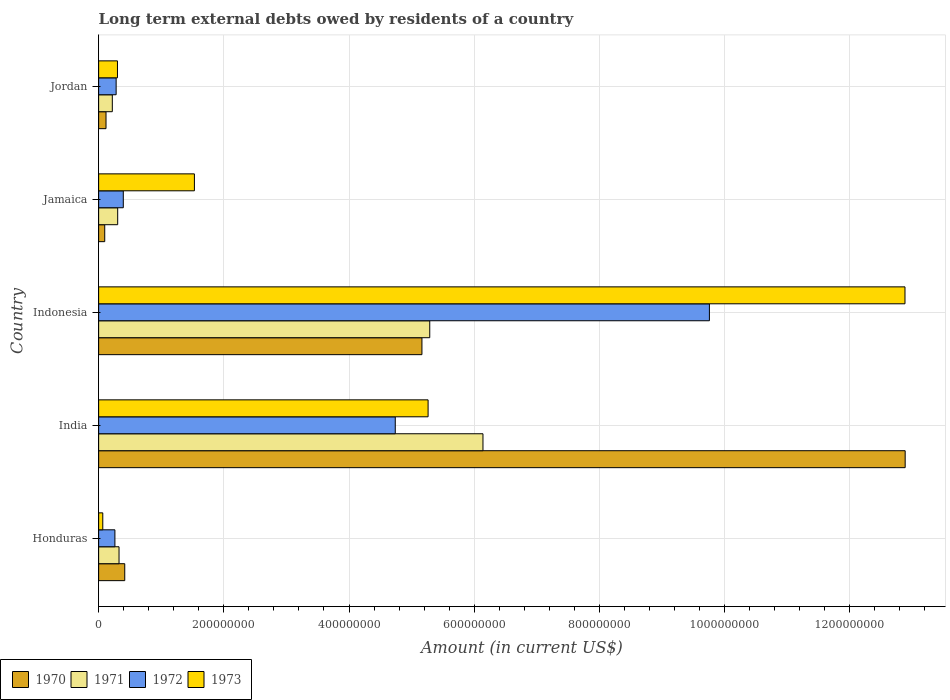How many groups of bars are there?
Ensure brevity in your answer.  5. Are the number of bars on each tick of the Y-axis equal?
Your response must be concise. Yes. How many bars are there on the 3rd tick from the top?
Provide a succinct answer. 4. What is the label of the 2nd group of bars from the top?
Provide a succinct answer. Jamaica. What is the amount of long-term external debts owed by residents in 1973 in Jamaica?
Offer a terse response. 1.53e+08. Across all countries, what is the maximum amount of long-term external debts owed by residents in 1973?
Make the answer very short. 1.29e+09. Across all countries, what is the minimum amount of long-term external debts owed by residents in 1972?
Your answer should be compact. 2.60e+07. In which country was the amount of long-term external debts owed by residents in 1970 maximum?
Ensure brevity in your answer.  India. In which country was the amount of long-term external debts owed by residents in 1973 minimum?
Your answer should be very brief. Honduras. What is the total amount of long-term external debts owed by residents in 1970 in the graph?
Provide a short and direct response. 1.87e+09. What is the difference between the amount of long-term external debts owed by residents in 1973 in India and that in Indonesia?
Provide a succinct answer. -7.62e+08. What is the difference between the amount of long-term external debts owed by residents in 1971 in Honduras and the amount of long-term external debts owed by residents in 1972 in Indonesia?
Your response must be concise. -9.43e+08. What is the average amount of long-term external debts owed by residents in 1971 per country?
Offer a terse response. 2.46e+08. What is the difference between the amount of long-term external debts owed by residents in 1971 and amount of long-term external debts owed by residents in 1973 in India?
Your response must be concise. 8.77e+07. In how many countries, is the amount of long-term external debts owed by residents in 1973 greater than 280000000 US$?
Provide a succinct answer. 2. What is the ratio of the amount of long-term external debts owed by residents in 1973 in Indonesia to that in Jamaica?
Ensure brevity in your answer.  8.42. Is the amount of long-term external debts owed by residents in 1970 in Honduras less than that in Jamaica?
Your answer should be very brief. No. What is the difference between the highest and the second highest amount of long-term external debts owed by residents in 1971?
Keep it short and to the point. 8.50e+07. What is the difference between the highest and the lowest amount of long-term external debts owed by residents in 1970?
Give a very brief answer. 1.28e+09. In how many countries, is the amount of long-term external debts owed by residents in 1972 greater than the average amount of long-term external debts owed by residents in 1972 taken over all countries?
Offer a very short reply. 2. Is it the case that in every country, the sum of the amount of long-term external debts owed by residents in 1972 and amount of long-term external debts owed by residents in 1973 is greater than the amount of long-term external debts owed by residents in 1970?
Ensure brevity in your answer.  No. Are all the bars in the graph horizontal?
Ensure brevity in your answer.  Yes. What is the difference between two consecutive major ticks on the X-axis?
Your answer should be very brief. 2.00e+08. Does the graph contain grids?
Offer a very short reply. Yes. Where does the legend appear in the graph?
Your response must be concise. Bottom left. How are the legend labels stacked?
Provide a short and direct response. Horizontal. What is the title of the graph?
Your answer should be compact. Long term external debts owed by residents of a country. Does "1994" appear as one of the legend labels in the graph?
Your answer should be compact. No. What is the label or title of the X-axis?
Offer a terse response. Amount (in current US$). What is the Amount (in current US$) in 1970 in Honduras?
Keep it short and to the point. 4.17e+07. What is the Amount (in current US$) of 1971 in Honduras?
Offer a terse response. 3.26e+07. What is the Amount (in current US$) in 1972 in Honduras?
Your answer should be very brief. 2.60e+07. What is the Amount (in current US$) of 1973 in Honduras?
Keep it short and to the point. 6.62e+06. What is the Amount (in current US$) in 1970 in India?
Offer a terse response. 1.29e+09. What is the Amount (in current US$) of 1971 in India?
Your answer should be very brief. 6.14e+08. What is the Amount (in current US$) in 1972 in India?
Keep it short and to the point. 4.74e+08. What is the Amount (in current US$) in 1973 in India?
Keep it short and to the point. 5.26e+08. What is the Amount (in current US$) of 1970 in Indonesia?
Make the answer very short. 5.17e+08. What is the Amount (in current US$) of 1971 in Indonesia?
Your answer should be compact. 5.29e+08. What is the Amount (in current US$) in 1972 in Indonesia?
Give a very brief answer. 9.76e+08. What is the Amount (in current US$) of 1973 in Indonesia?
Provide a succinct answer. 1.29e+09. What is the Amount (in current US$) in 1970 in Jamaica?
Your answer should be very brief. 9.74e+06. What is the Amount (in current US$) in 1971 in Jamaica?
Provide a short and direct response. 3.04e+07. What is the Amount (in current US$) in 1972 in Jamaica?
Offer a very short reply. 3.94e+07. What is the Amount (in current US$) of 1973 in Jamaica?
Your answer should be very brief. 1.53e+08. What is the Amount (in current US$) of 1970 in Jordan?
Make the answer very short. 1.18e+07. What is the Amount (in current US$) of 1971 in Jordan?
Your response must be concise. 2.18e+07. What is the Amount (in current US$) of 1972 in Jordan?
Your answer should be compact. 2.80e+07. What is the Amount (in current US$) of 1973 in Jordan?
Provide a short and direct response. 3.01e+07. Across all countries, what is the maximum Amount (in current US$) in 1970?
Offer a very short reply. 1.29e+09. Across all countries, what is the maximum Amount (in current US$) in 1971?
Ensure brevity in your answer.  6.14e+08. Across all countries, what is the maximum Amount (in current US$) in 1972?
Give a very brief answer. 9.76e+08. Across all countries, what is the maximum Amount (in current US$) in 1973?
Provide a short and direct response. 1.29e+09. Across all countries, what is the minimum Amount (in current US$) in 1970?
Make the answer very short. 9.74e+06. Across all countries, what is the minimum Amount (in current US$) of 1971?
Provide a short and direct response. 2.18e+07. Across all countries, what is the minimum Amount (in current US$) in 1972?
Your answer should be compact. 2.60e+07. Across all countries, what is the minimum Amount (in current US$) of 1973?
Keep it short and to the point. 6.62e+06. What is the total Amount (in current US$) in 1970 in the graph?
Provide a short and direct response. 1.87e+09. What is the total Amount (in current US$) of 1971 in the graph?
Give a very brief answer. 1.23e+09. What is the total Amount (in current US$) in 1972 in the graph?
Your answer should be compact. 1.54e+09. What is the total Amount (in current US$) in 1973 in the graph?
Your response must be concise. 2.00e+09. What is the difference between the Amount (in current US$) in 1970 in Honduras and that in India?
Provide a succinct answer. -1.25e+09. What is the difference between the Amount (in current US$) of 1971 in Honduras and that in India?
Give a very brief answer. -5.81e+08. What is the difference between the Amount (in current US$) of 1972 in Honduras and that in India?
Ensure brevity in your answer.  -4.48e+08. What is the difference between the Amount (in current US$) in 1973 in Honduras and that in India?
Make the answer very short. -5.20e+08. What is the difference between the Amount (in current US$) in 1970 in Honduras and that in Indonesia?
Provide a succinct answer. -4.75e+08. What is the difference between the Amount (in current US$) in 1971 in Honduras and that in Indonesia?
Your response must be concise. -4.96e+08. What is the difference between the Amount (in current US$) in 1972 in Honduras and that in Indonesia?
Your answer should be compact. -9.50e+08. What is the difference between the Amount (in current US$) of 1973 in Honduras and that in Indonesia?
Offer a terse response. -1.28e+09. What is the difference between the Amount (in current US$) of 1970 in Honduras and that in Jamaica?
Offer a very short reply. 3.20e+07. What is the difference between the Amount (in current US$) of 1971 in Honduras and that in Jamaica?
Provide a succinct answer. 2.17e+06. What is the difference between the Amount (in current US$) of 1972 in Honduras and that in Jamaica?
Your response must be concise. -1.34e+07. What is the difference between the Amount (in current US$) in 1973 in Honduras and that in Jamaica?
Your response must be concise. -1.46e+08. What is the difference between the Amount (in current US$) in 1970 in Honduras and that in Jordan?
Give a very brief answer. 2.99e+07. What is the difference between the Amount (in current US$) of 1971 in Honduras and that in Jordan?
Make the answer very short. 1.08e+07. What is the difference between the Amount (in current US$) in 1972 in Honduras and that in Jordan?
Your response must be concise. -1.96e+06. What is the difference between the Amount (in current US$) in 1973 in Honduras and that in Jordan?
Make the answer very short. -2.35e+07. What is the difference between the Amount (in current US$) of 1970 in India and that in Indonesia?
Your response must be concise. 7.72e+08. What is the difference between the Amount (in current US$) of 1971 in India and that in Indonesia?
Make the answer very short. 8.50e+07. What is the difference between the Amount (in current US$) of 1972 in India and that in Indonesia?
Give a very brief answer. -5.02e+08. What is the difference between the Amount (in current US$) of 1973 in India and that in Indonesia?
Your answer should be very brief. -7.62e+08. What is the difference between the Amount (in current US$) in 1970 in India and that in Jamaica?
Give a very brief answer. 1.28e+09. What is the difference between the Amount (in current US$) in 1971 in India and that in Jamaica?
Your response must be concise. 5.84e+08. What is the difference between the Amount (in current US$) in 1972 in India and that in Jamaica?
Your answer should be compact. 4.34e+08. What is the difference between the Amount (in current US$) in 1973 in India and that in Jamaica?
Your answer should be very brief. 3.73e+08. What is the difference between the Amount (in current US$) in 1970 in India and that in Jordan?
Offer a very short reply. 1.28e+09. What is the difference between the Amount (in current US$) in 1971 in India and that in Jordan?
Your response must be concise. 5.92e+08. What is the difference between the Amount (in current US$) in 1972 in India and that in Jordan?
Your answer should be very brief. 4.46e+08. What is the difference between the Amount (in current US$) of 1973 in India and that in Jordan?
Offer a terse response. 4.96e+08. What is the difference between the Amount (in current US$) of 1970 in Indonesia and that in Jamaica?
Offer a terse response. 5.07e+08. What is the difference between the Amount (in current US$) in 1971 in Indonesia and that in Jamaica?
Your answer should be compact. 4.99e+08. What is the difference between the Amount (in current US$) in 1972 in Indonesia and that in Jamaica?
Ensure brevity in your answer.  9.36e+08. What is the difference between the Amount (in current US$) in 1973 in Indonesia and that in Jamaica?
Keep it short and to the point. 1.14e+09. What is the difference between the Amount (in current US$) in 1970 in Indonesia and that in Jordan?
Provide a succinct answer. 5.05e+08. What is the difference between the Amount (in current US$) in 1971 in Indonesia and that in Jordan?
Give a very brief answer. 5.07e+08. What is the difference between the Amount (in current US$) in 1972 in Indonesia and that in Jordan?
Provide a short and direct response. 9.48e+08. What is the difference between the Amount (in current US$) of 1973 in Indonesia and that in Jordan?
Make the answer very short. 1.26e+09. What is the difference between the Amount (in current US$) of 1970 in Jamaica and that in Jordan?
Make the answer very short. -2.06e+06. What is the difference between the Amount (in current US$) in 1971 in Jamaica and that in Jordan?
Your answer should be compact. 8.59e+06. What is the difference between the Amount (in current US$) of 1972 in Jamaica and that in Jordan?
Keep it short and to the point. 1.14e+07. What is the difference between the Amount (in current US$) of 1973 in Jamaica and that in Jordan?
Your answer should be very brief. 1.23e+08. What is the difference between the Amount (in current US$) of 1970 in Honduras and the Amount (in current US$) of 1971 in India?
Give a very brief answer. -5.72e+08. What is the difference between the Amount (in current US$) in 1970 in Honduras and the Amount (in current US$) in 1972 in India?
Provide a short and direct response. -4.32e+08. What is the difference between the Amount (in current US$) of 1970 in Honduras and the Amount (in current US$) of 1973 in India?
Your response must be concise. -4.85e+08. What is the difference between the Amount (in current US$) of 1971 in Honduras and the Amount (in current US$) of 1972 in India?
Give a very brief answer. -4.41e+08. What is the difference between the Amount (in current US$) in 1971 in Honduras and the Amount (in current US$) in 1973 in India?
Give a very brief answer. -4.94e+08. What is the difference between the Amount (in current US$) in 1972 in Honduras and the Amount (in current US$) in 1973 in India?
Your response must be concise. -5.00e+08. What is the difference between the Amount (in current US$) in 1970 in Honduras and the Amount (in current US$) in 1971 in Indonesia?
Ensure brevity in your answer.  -4.87e+08. What is the difference between the Amount (in current US$) in 1970 in Honduras and the Amount (in current US$) in 1972 in Indonesia?
Provide a succinct answer. -9.34e+08. What is the difference between the Amount (in current US$) of 1970 in Honduras and the Amount (in current US$) of 1973 in Indonesia?
Offer a very short reply. -1.25e+09. What is the difference between the Amount (in current US$) of 1971 in Honduras and the Amount (in current US$) of 1972 in Indonesia?
Your response must be concise. -9.43e+08. What is the difference between the Amount (in current US$) in 1971 in Honduras and the Amount (in current US$) in 1973 in Indonesia?
Make the answer very short. -1.26e+09. What is the difference between the Amount (in current US$) in 1972 in Honduras and the Amount (in current US$) in 1973 in Indonesia?
Ensure brevity in your answer.  -1.26e+09. What is the difference between the Amount (in current US$) of 1970 in Honduras and the Amount (in current US$) of 1971 in Jamaica?
Offer a terse response. 1.13e+07. What is the difference between the Amount (in current US$) of 1970 in Honduras and the Amount (in current US$) of 1972 in Jamaica?
Provide a succinct answer. 2.33e+06. What is the difference between the Amount (in current US$) of 1970 in Honduras and the Amount (in current US$) of 1973 in Jamaica?
Your answer should be very brief. -1.11e+08. What is the difference between the Amount (in current US$) in 1971 in Honduras and the Amount (in current US$) in 1972 in Jamaica?
Provide a succinct answer. -6.81e+06. What is the difference between the Amount (in current US$) in 1971 in Honduras and the Amount (in current US$) in 1973 in Jamaica?
Your answer should be compact. -1.20e+08. What is the difference between the Amount (in current US$) of 1972 in Honduras and the Amount (in current US$) of 1973 in Jamaica?
Your answer should be very brief. -1.27e+08. What is the difference between the Amount (in current US$) of 1970 in Honduras and the Amount (in current US$) of 1971 in Jordan?
Your answer should be compact. 1.99e+07. What is the difference between the Amount (in current US$) in 1970 in Honduras and the Amount (in current US$) in 1972 in Jordan?
Offer a very short reply. 1.38e+07. What is the difference between the Amount (in current US$) in 1970 in Honduras and the Amount (in current US$) in 1973 in Jordan?
Your answer should be very brief. 1.16e+07. What is the difference between the Amount (in current US$) of 1971 in Honduras and the Amount (in current US$) of 1972 in Jordan?
Offer a terse response. 4.63e+06. What is the difference between the Amount (in current US$) of 1971 in Honduras and the Amount (in current US$) of 1973 in Jordan?
Your answer should be very brief. 2.51e+06. What is the difference between the Amount (in current US$) of 1972 in Honduras and the Amount (in current US$) of 1973 in Jordan?
Your answer should be very brief. -4.08e+06. What is the difference between the Amount (in current US$) of 1970 in India and the Amount (in current US$) of 1971 in Indonesia?
Offer a terse response. 7.60e+08. What is the difference between the Amount (in current US$) in 1970 in India and the Amount (in current US$) in 1972 in Indonesia?
Make the answer very short. 3.13e+08. What is the difference between the Amount (in current US$) in 1970 in India and the Amount (in current US$) in 1973 in Indonesia?
Your answer should be very brief. 3.01e+05. What is the difference between the Amount (in current US$) of 1971 in India and the Amount (in current US$) of 1972 in Indonesia?
Provide a succinct answer. -3.62e+08. What is the difference between the Amount (in current US$) in 1971 in India and the Amount (in current US$) in 1973 in Indonesia?
Make the answer very short. -6.74e+08. What is the difference between the Amount (in current US$) in 1972 in India and the Amount (in current US$) in 1973 in Indonesia?
Ensure brevity in your answer.  -8.14e+08. What is the difference between the Amount (in current US$) in 1970 in India and the Amount (in current US$) in 1971 in Jamaica?
Provide a short and direct response. 1.26e+09. What is the difference between the Amount (in current US$) of 1970 in India and the Amount (in current US$) of 1972 in Jamaica?
Offer a terse response. 1.25e+09. What is the difference between the Amount (in current US$) in 1970 in India and the Amount (in current US$) in 1973 in Jamaica?
Your answer should be compact. 1.14e+09. What is the difference between the Amount (in current US$) in 1971 in India and the Amount (in current US$) in 1972 in Jamaica?
Make the answer very short. 5.75e+08. What is the difference between the Amount (in current US$) in 1971 in India and the Amount (in current US$) in 1973 in Jamaica?
Keep it short and to the point. 4.61e+08. What is the difference between the Amount (in current US$) in 1972 in India and the Amount (in current US$) in 1973 in Jamaica?
Provide a short and direct response. 3.21e+08. What is the difference between the Amount (in current US$) in 1970 in India and the Amount (in current US$) in 1971 in Jordan?
Your answer should be very brief. 1.27e+09. What is the difference between the Amount (in current US$) in 1970 in India and the Amount (in current US$) in 1972 in Jordan?
Make the answer very short. 1.26e+09. What is the difference between the Amount (in current US$) in 1970 in India and the Amount (in current US$) in 1973 in Jordan?
Your answer should be very brief. 1.26e+09. What is the difference between the Amount (in current US$) of 1971 in India and the Amount (in current US$) of 1972 in Jordan?
Offer a terse response. 5.86e+08. What is the difference between the Amount (in current US$) in 1971 in India and the Amount (in current US$) in 1973 in Jordan?
Keep it short and to the point. 5.84e+08. What is the difference between the Amount (in current US$) in 1972 in India and the Amount (in current US$) in 1973 in Jordan?
Your response must be concise. 4.44e+08. What is the difference between the Amount (in current US$) in 1970 in Indonesia and the Amount (in current US$) in 1971 in Jamaica?
Your answer should be compact. 4.86e+08. What is the difference between the Amount (in current US$) in 1970 in Indonesia and the Amount (in current US$) in 1972 in Jamaica?
Your response must be concise. 4.77e+08. What is the difference between the Amount (in current US$) in 1970 in Indonesia and the Amount (in current US$) in 1973 in Jamaica?
Provide a succinct answer. 3.64e+08. What is the difference between the Amount (in current US$) of 1971 in Indonesia and the Amount (in current US$) of 1972 in Jamaica?
Your answer should be very brief. 4.90e+08. What is the difference between the Amount (in current US$) in 1971 in Indonesia and the Amount (in current US$) in 1973 in Jamaica?
Your answer should be compact. 3.76e+08. What is the difference between the Amount (in current US$) of 1972 in Indonesia and the Amount (in current US$) of 1973 in Jamaica?
Make the answer very short. 8.23e+08. What is the difference between the Amount (in current US$) of 1970 in Indonesia and the Amount (in current US$) of 1971 in Jordan?
Your answer should be compact. 4.95e+08. What is the difference between the Amount (in current US$) of 1970 in Indonesia and the Amount (in current US$) of 1972 in Jordan?
Provide a short and direct response. 4.89e+08. What is the difference between the Amount (in current US$) in 1970 in Indonesia and the Amount (in current US$) in 1973 in Jordan?
Give a very brief answer. 4.86e+08. What is the difference between the Amount (in current US$) in 1971 in Indonesia and the Amount (in current US$) in 1972 in Jordan?
Offer a very short reply. 5.01e+08. What is the difference between the Amount (in current US$) of 1971 in Indonesia and the Amount (in current US$) of 1973 in Jordan?
Give a very brief answer. 4.99e+08. What is the difference between the Amount (in current US$) of 1972 in Indonesia and the Amount (in current US$) of 1973 in Jordan?
Provide a succinct answer. 9.46e+08. What is the difference between the Amount (in current US$) of 1970 in Jamaica and the Amount (in current US$) of 1971 in Jordan?
Make the answer very short. -1.21e+07. What is the difference between the Amount (in current US$) of 1970 in Jamaica and the Amount (in current US$) of 1972 in Jordan?
Offer a terse response. -1.82e+07. What is the difference between the Amount (in current US$) of 1970 in Jamaica and the Amount (in current US$) of 1973 in Jordan?
Provide a succinct answer. -2.04e+07. What is the difference between the Amount (in current US$) of 1971 in Jamaica and the Amount (in current US$) of 1972 in Jordan?
Provide a short and direct response. 2.46e+06. What is the difference between the Amount (in current US$) of 1971 in Jamaica and the Amount (in current US$) of 1973 in Jordan?
Provide a short and direct response. 3.43e+05. What is the difference between the Amount (in current US$) of 1972 in Jamaica and the Amount (in current US$) of 1973 in Jordan?
Keep it short and to the point. 9.32e+06. What is the average Amount (in current US$) in 1970 per country?
Your answer should be very brief. 3.74e+08. What is the average Amount (in current US$) in 1971 per country?
Offer a very short reply. 2.46e+08. What is the average Amount (in current US$) of 1972 per country?
Give a very brief answer. 3.09e+08. What is the average Amount (in current US$) of 1973 per country?
Your answer should be very brief. 4.01e+08. What is the difference between the Amount (in current US$) in 1970 and Amount (in current US$) in 1971 in Honduras?
Provide a short and direct response. 9.13e+06. What is the difference between the Amount (in current US$) in 1970 and Amount (in current US$) in 1972 in Honduras?
Offer a terse response. 1.57e+07. What is the difference between the Amount (in current US$) of 1970 and Amount (in current US$) of 1973 in Honduras?
Provide a short and direct response. 3.51e+07. What is the difference between the Amount (in current US$) of 1971 and Amount (in current US$) of 1972 in Honduras?
Provide a short and direct response. 6.59e+06. What is the difference between the Amount (in current US$) of 1971 and Amount (in current US$) of 1973 in Honduras?
Your answer should be very brief. 2.60e+07. What is the difference between the Amount (in current US$) in 1972 and Amount (in current US$) in 1973 in Honduras?
Keep it short and to the point. 1.94e+07. What is the difference between the Amount (in current US$) in 1970 and Amount (in current US$) in 1971 in India?
Provide a succinct answer. 6.74e+08. What is the difference between the Amount (in current US$) of 1970 and Amount (in current US$) of 1972 in India?
Provide a short and direct response. 8.15e+08. What is the difference between the Amount (in current US$) of 1970 and Amount (in current US$) of 1973 in India?
Your response must be concise. 7.62e+08. What is the difference between the Amount (in current US$) of 1971 and Amount (in current US$) of 1972 in India?
Your response must be concise. 1.40e+08. What is the difference between the Amount (in current US$) in 1971 and Amount (in current US$) in 1973 in India?
Offer a terse response. 8.77e+07. What is the difference between the Amount (in current US$) in 1972 and Amount (in current US$) in 1973 in India?
Provide a succinct answer. -5.24e+07. What is the difference between the Amount (in current US$) of 1970 and Amount (in current US$) of 1971 in Indonesia?
Offer a very short reply. -1.25e+07. What is the difference between the Amount (in current US$) of 1970 and Amount (in current US$) of 1972 in Indonesia?
Provide a succinct answer. -4.59e+08. What is the difference between the Amount (in current US$) of 1970 and Amount (in current US$) of 1973 in Indonesia?
Your answer should be very brief. -7.72e+08. What is the difference between the Amount (in current US$) in 1971 and Amount (in current US$) in 1972 in Indonesia?
Offer a very short reply. -4.47e+08. What is the difference between the Amount (in current US$) in 1971 and Amount (in current US$) in 1973 in Indonesia?
Provide a short and direct response. -7.59e+08. What is the difference between the Amount (in current US$) in 1972 and Amount (in current US$) in 1973 in Indonesia?
Ensure brevity in your answer.  -3.12e+08. What is the difference between the Amount (in current US$) of 1970 and Amount (in current US$) of 1971 in Jamaica?
Offer a terse response. -2.07e+07. What is the difference between the Amount (in current US$) of 1970 and Amount (in current US$) of 1972 in Jamaica?
Give a very brief answer. -2.97e+07. What is the difference between the Amount (in current US$) of 1970 and Amount (in current US$) of 1973 in Jamaica?
Your answer should be compact. -1.43e+08. What is the difference between the Amount (in current US$) of 1971 and Amount (in current US$) of 1972 in Jamaica?
Keep it short and to the point. -8.97e+06. What is the difference between the Amount (in current US$) of 1971 and Amount (in current US$) of 1973 in Jamaica?
Provide a short and direct response. -1.23e+08. What is the difference between the Amount (in current US$) of 1972 and Amount (in current US$) of 1973 in Jamaica?
Ensure brevity in your answer.  -1.14e+08. What is the difference between the Amount (in current US$) of 1970 and Amount (in current US$) of 1971 in Jordan?
Your response must be concise. -1.00e+07. What is the difference between the Amount (in current US$) of 1970 and Amount (in current US$) of 1972 in Jordan?
Offer a very short reply. -1.62e+07. What is the difference between the Amount (in current US$) in 1970 and Amount (in current US$) in 1973 in Jordan?
Ensure brevity in your answer.  -1.83e+07. What is the difference between the Amount (in current US$) in 1971 and Amount (in current US$) in 1972 in Jordan?
Your response must be concise. -6.12e+06. What is the difference between the Amount (in current US$) of 1971 and Amount (in current US$) of 1973 in Jordan?
Offer a very short reply. -8.24e+06. What is the difference between the Amount (in current US$) in 1972 and Amount (in current US$) in 1973 in Jordan?
Provide a succinct answer. -2.12e+06. What is the ratio of the Amount (in current US$) of 1970 in Honduras to that in India?
Keep it short and to the point. 0.03. What is the ratio of the Amount (in current US$) of 1971 in Honduras to that in India?
Offer a terse response. 0.05. What is the ratio of the Amount (in current US$) in 1972 in Honduras to that in India?
Offer a very short reply. 0.05. What is the ratio of the Amount (in current US$) in 1973 in Honduras to that in India?
Provide a succinct answer. 0.01. What is the ratio of the Amount (in current US$) in 1970 in Honduras to that in Indonesia?
Keep it short and to the point. 0.08. What is the ratio of the Amount (in current US$) in 1971 in Honduras to that in Indonesia?
Keep it short and to the point. 0.06. What is the ratio of the Amount (in current US$) in 1972 in Honduras to that in Indonesia?
Make the answer very short. 0.03. What is the ratio of the Amount (in current US$) in 1973 in Honduras to that in Indonesia?
Offer a terse response. 0.01. What is the ratio of the Amount (in current US$) of 1970 in Honduras to that in Jamaica?
Offer a terse response. 4.29. What is the ratio of the Amount (in current US$) in 1971 in Honduras to that in Jamaica?
Provide a succinct answer. 1.07. What is the ratio of the Amount (in current US$) in 1972 in Honduras to that in Jamaica?
Ensure brevity in your answer.  0.66. What is the ratio of the Amount (in current US$) in 1973 in Honduras to that in Jamaica?
Ensure brevity in your answer.  0.04. What is the ratio of the Amount (in current US$) of 1970 in Honduras to that in Jordan?
Keep it short and to the point. 3.54. What is the ratio of the Amount (in current US$) in 1971 in Honduras to that in Jordan?
Provide a short and direct response. 1.49. What is the ratio of the Amount (in current US$) of 1972 in Honduras to that in Jordan?
Offer a terse response. 0.93. What is the ratio of the Amount (in current US$) in 1973 in Honduras to that in Jordan?
Make the answer very short. 0.22. What is the ratio of the Amount (in current US$) in 1970 in India to that in Indonesia?
Offer a terse response. 2.49. What is the ratio of the Amount (in current US$) in 1971 in India to that in Indonesia?
Offer a very short reply. 1.16. What is the ratio of the Amount (in current US$) in 1972 in India to that in Indonesia?
Your answer should be compact. 0.49. What is the ratio of the Amount (in current US$) of 1973 in India to that in Indonesia?
Your response must be concise. 0.41. What is the ratio of the Amount (in current US$) of 1970 in India to that in Jamaica?
Your answer should be very brief. 132.34. What is the ratio of the Amount (in current US$) of 1971 in India to that in Jamaica?
Provide a succinct answer. 20.18. What is the ratio of the Amount (in current US$) in 1972 in India to that in Jamaica?
Your response must be concise. 12.03. What is the ratio of the Amount (in current US$) in 1973 in India to that in Jamaica?
Give a very brief answer. 3.44. What is the ratio of the Amount (in current US$) in 1970 in India to that in Jordan?
Keep it short and to the point. 109.2. What is the ratio of the Amount (in current US$) in 1971 in India to that in Jordan?
Provide a succinct answer. 28.11. What is the ratio of the Amount (in current US$) in 1972 in India to that in Jordan?
Offer a very short reply. 16.95. What is the ratio of the Amount (in current US$) in 1973 in India to that in Jordan?
Provide a succinct answer. 17.49. What is the ratio of the Amount (in current US$) of 1970 in Indonesia to that in Jamaica?
Give a very brief answer. 53.05. What is the ratio of the Amount (in current US$) of 1971 in Indonesia to that in Jamaica?
Your response must be concise. 17.38. What is the ratio of the Amount (in current US$) of 1972 in Indonesia to that in Jamaica?
Provide a short and direct response. 24.76. What is the ratio of the Amount (in current US$) in 1973 in Indonesia to that in Jamaica?
Your response must be concise. 8.42. What is the ratio of the Amount (in current US$) in 1970 in Indonesia to that in Jordan?
Give a very brief answer. 43.77. What is the ratio of the Amount (in current US$) of 1971 in Indonesia to that in Jordan?
Make the answer very short. 24.22. What is the ratio of the Amount (in current US$) in 1972 in Indonesia to that in Jordan?
Offer a terse response. 34.89. What is the ratio of the Amount (in current US$) of 1973 in Indonesia to that in Jordan?
Your response must be concise. 42.81. What is the ratio of the Amount (in current US$) of 1970 in Jamaica to that in Jordan?
Ensure brevity in your answer.  0.83. What is the ratio of the Amount (in current US$) in 1971 in Jamaica to that in Jordan?
Offer a terse response. 1.39. What is the ratio of the Amount (in current US$) in 1972 in Jamaica to that in Jordan?
Make the answer very short. 1.41. What is the ratio of the Amount (in current US$) of 1973 in Jamaica to that in Jordan?
Your answer should be very brief. 5.08. What is the difference between the highest and the second highest Amount (in current US$) of 1970?
Your answer should be compact. 7.72e+08. What is the difference between the highest and the second highest Amount (in current US$) of 1971?
Give a very brief answer. 8.50e+07. What is the difference between the highest and the second highest Amount (in current US$) in 1972?
Ensure brevity in your answer.  5.02e+08. What is the difference between the highest and the second highest Amount (in current US$) of 1973?
Provide a succinct answer. 7.62e+08. What is the difference between the highest and the lowest Amount (in current US$) in 1970?
Keep it short and to the point. 1.28e+09. What is the difference between the highest and the lowest Amount (in current US$) of 1971?
Make the answer very short. 5.92e+08. What is the difference between the highest and the lowest Amount (in current US$) of 1972?
Provide a succinct answer. 9.50e+08. What is the difference between the highest and the lowest Amount (in current US$) of 1973?
Offer a very short reply. 1.28e+09. 